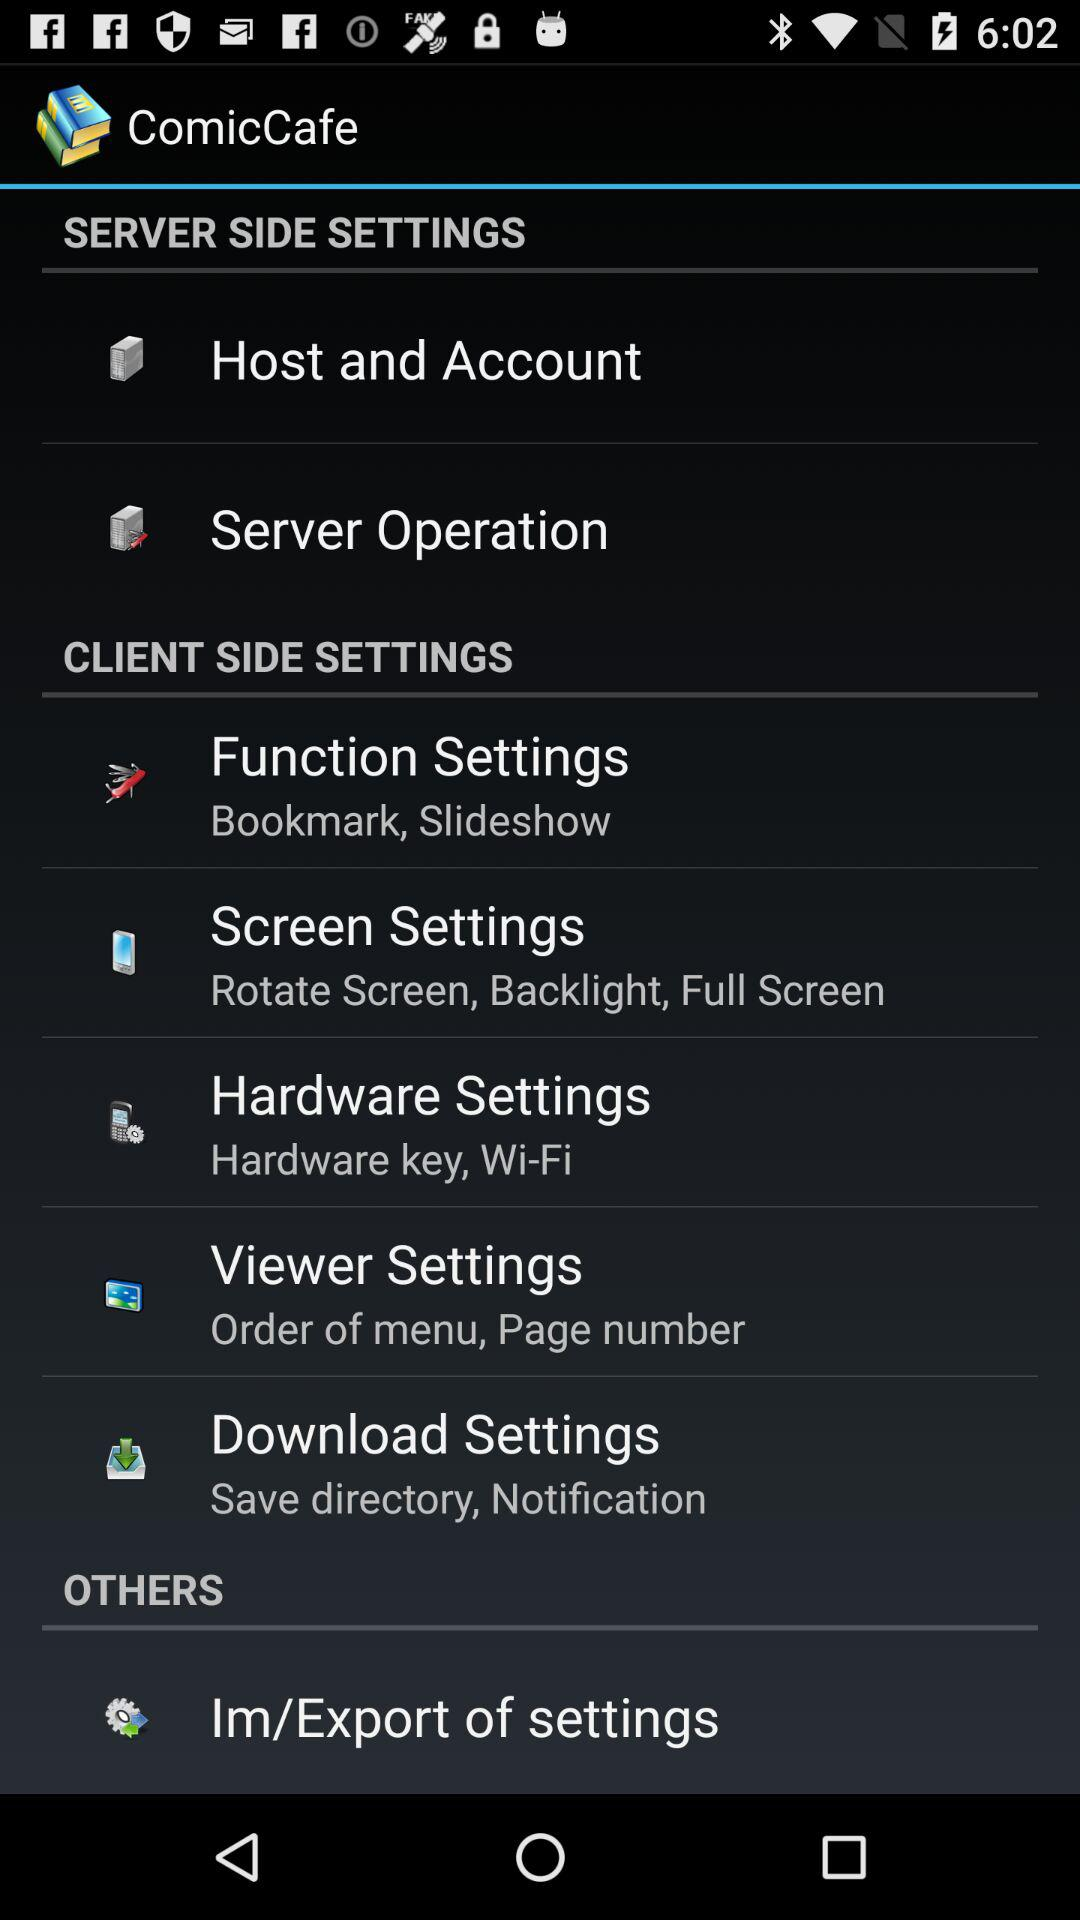Where do hardware keys and Wi-Fi appear? Hardware keys and Wi-Fi appear in "Hardware Settings". 